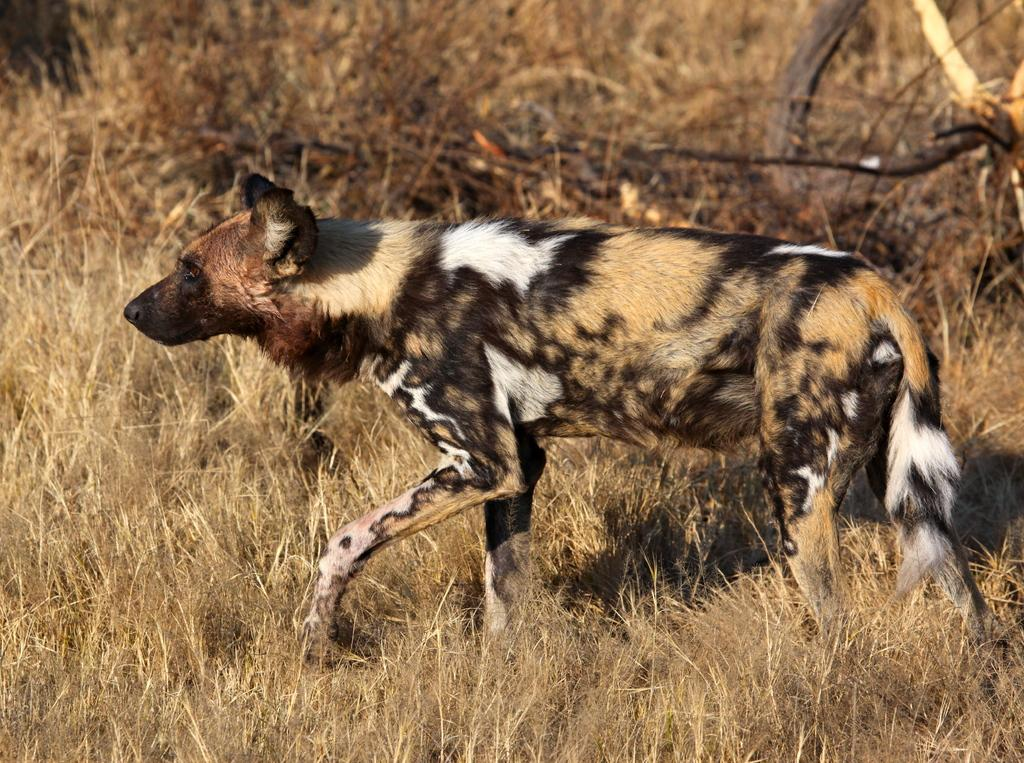What animal can be seen in the image? There is a hyena in the image. What is the hyena doing in the image? The hyena is walking. What type of vegetation is present in the image? There is dried grass in the image. What can be seen in the background of the image? There are branches visible in the background of the image. Can you tell me what type of cloud is present in the image? There is no cloud present in the image; it features a hyena walking in a grassy area with branches visible in the background. 